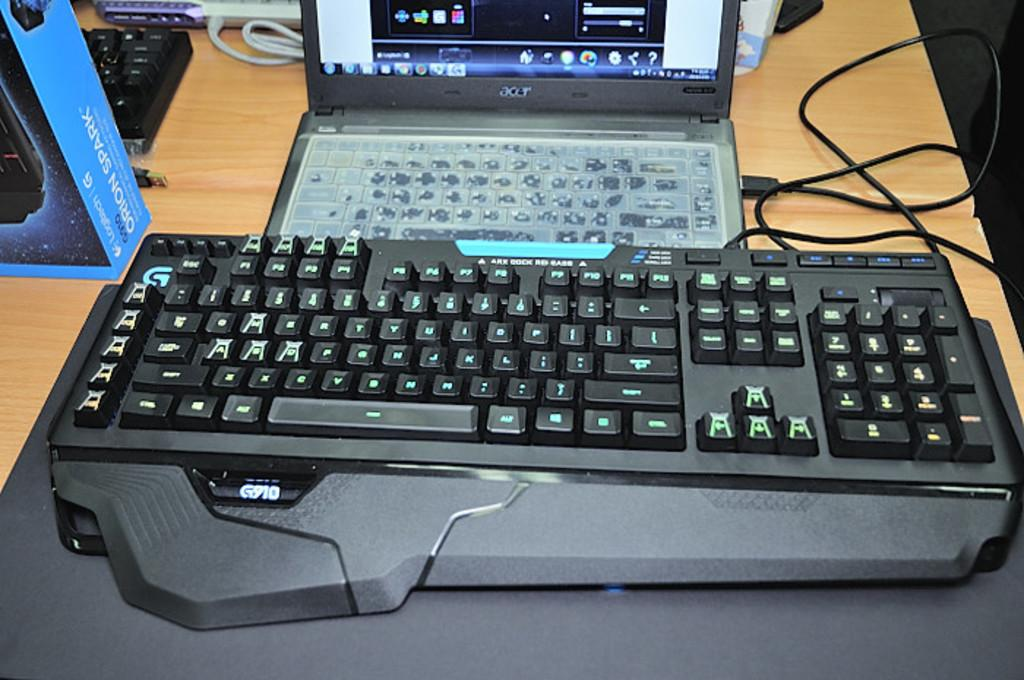<image>
Summarize the visual content of the image. A G910 keyboard is placed in front of a laptop. 